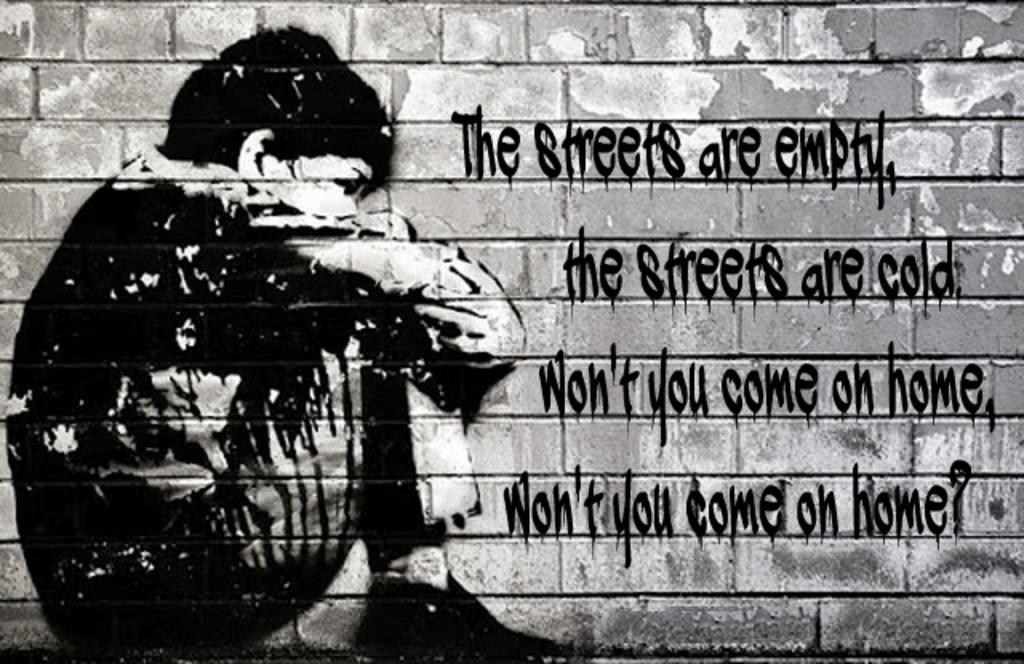Describe this image in one or two sentences. This image is consists of a painting on a wall. 